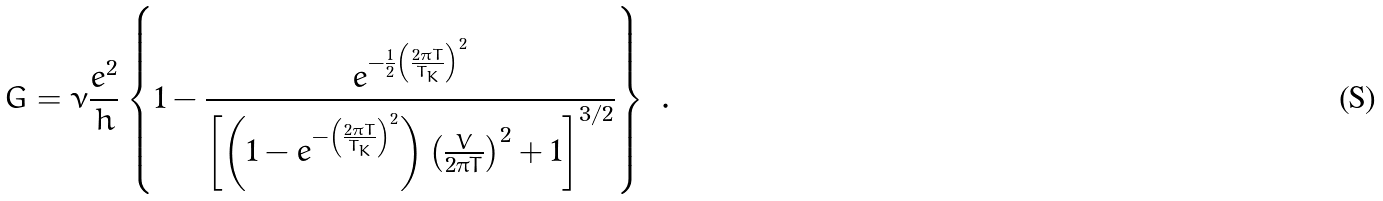<formula> <loc_0><loc_0><loc_500><loc_500>G = \nu \frac { e ^ { 2 } } { h } \left \{ 1 - \frac { e ^ { - \frac { 1 } { 2 } \left ( \frac { 2 \pi T } { T _ { K } } \right ) ^ { 2 } } } { \left [ \left ( 1 - e ^ { - \left ( \frac { 2 \pi T } { T _ { K } } \right ) ^ { 2 } } \right ) \left ( \frac { V } { 2 \pi T } \right ) ^ { 2 } + 1 \right ] ^ { 3 / 2 } } \right \} \ .</formula> 